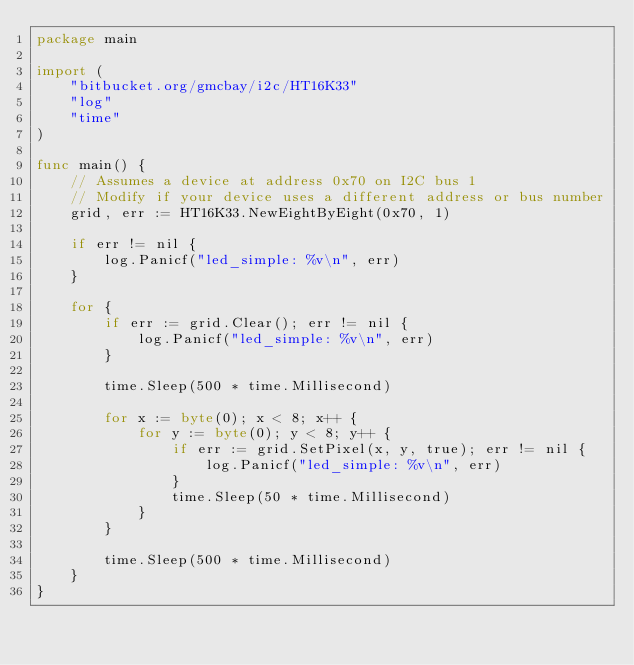Convert code to text. <code><loc_0><loc_0><loc_500><loc_500><_Go_>package main

import (
	"bitbucket.org/gmcbay/i2c/HT16K33"
	"log"
	"time"
)

func main() {
	// Assumes a device at address 0x70 on I2C bus 1
	// Modify if your device uses a different address or bus number
	grid, err := HT16K33.NewEightByEight(0x70, 1)

	if err != nil {
		log.Panicf("led_simple: %v\n", err)
	}

	for {
		if err := grid.Clear(); err != nil {
			log.Panicf("led_simple: %v\n", err)
		}

		time.Sleep(500 * time.Millisecond)

		for x := byte(0); x < 8; x++ {
			for y := byte(0); y < 8; y++ {
				if err := grid.SetPixel(x, y, true); err != nil {
					log.Panicf("led_simple: %v\n", err)
				}
				time.Sleep(50 * time.Millisecond)
			}
		}

		time.Sleep(500 * time.Millisecond)
	}
}
</code> 